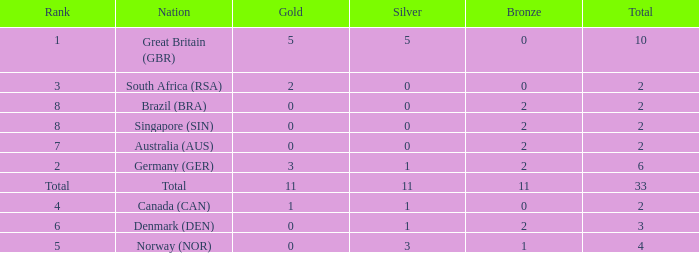What is the total when the nation is brazil (bra) and bronze is more than 2? None. 